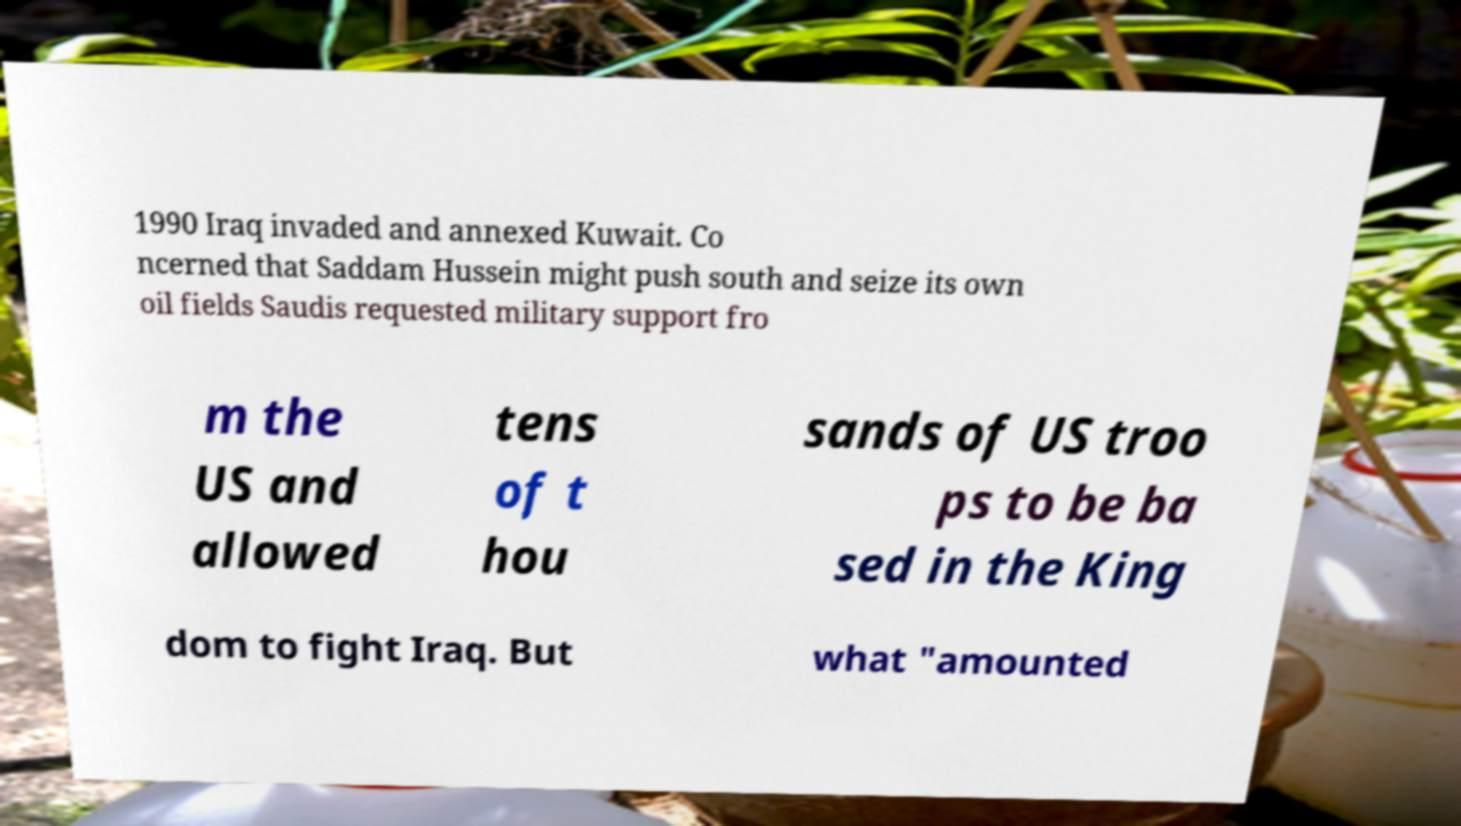Please identify and transcribe the text found in this image. 1990 Iraq invaded and annexed Kuwait. Co ncerned that Saddam Hussein might push south and seize its own oil fields Saudis requested military support fro m the US and allowed tens of t hou sands of US troo ps to be ba sed in the King dom to fight Iraq. But what "amounted 